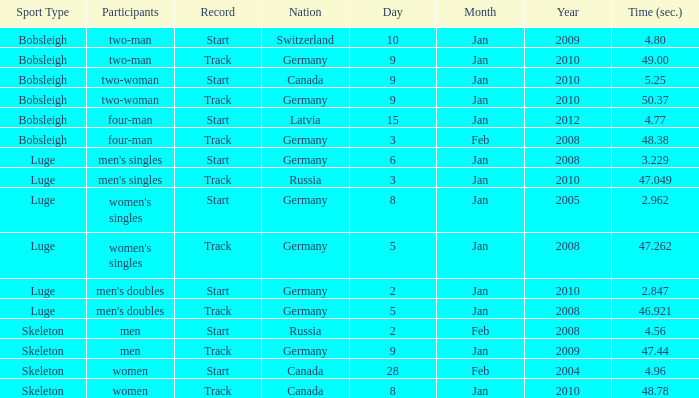Which nation finished with a time of 47.049? Russia. 